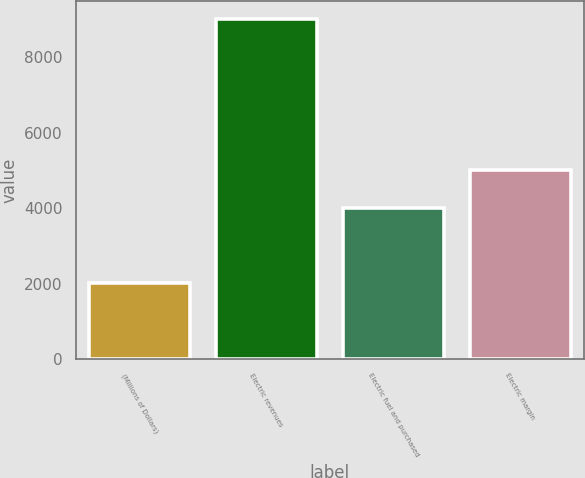<chart> <loc_0><loc_0><loc_500><loc_500><bar_chart><fcel>(Millions of Dollars)<fcel>Electric revenues<fcel>Electric fuel and purchased<fcel>Electric margin<nl><fcel>2013<fcel>9034<fcel>4019<fcel>5015<nl></chart> 